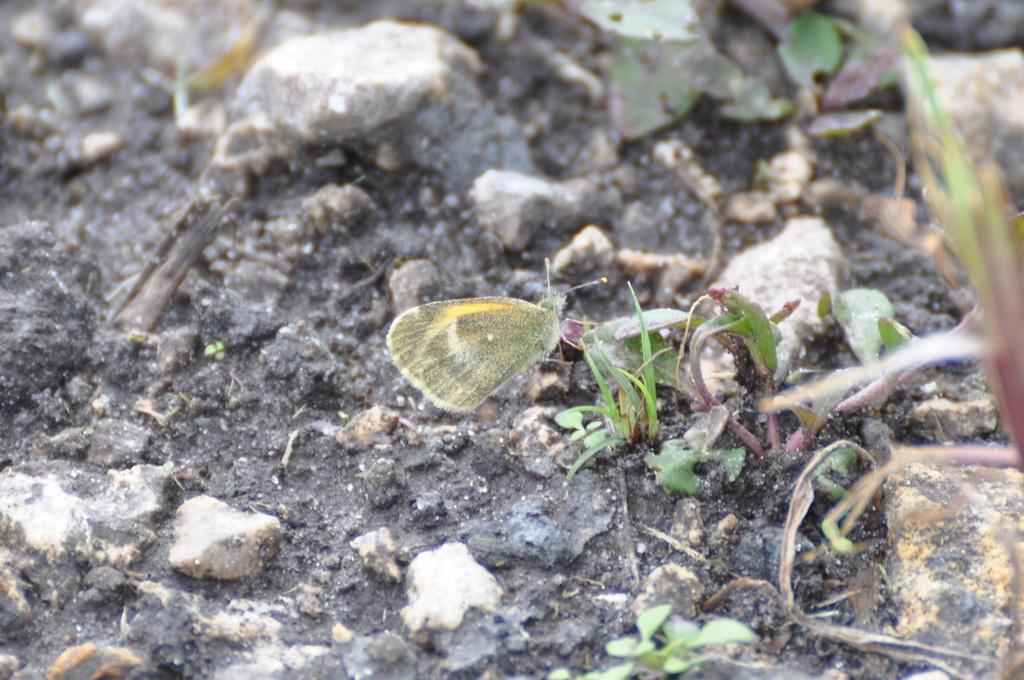In one or two sentences, can you explain what this image depicts? In this picture we can see a butterfly, at the bottom there is soil and some stones, we can see leaves here. 